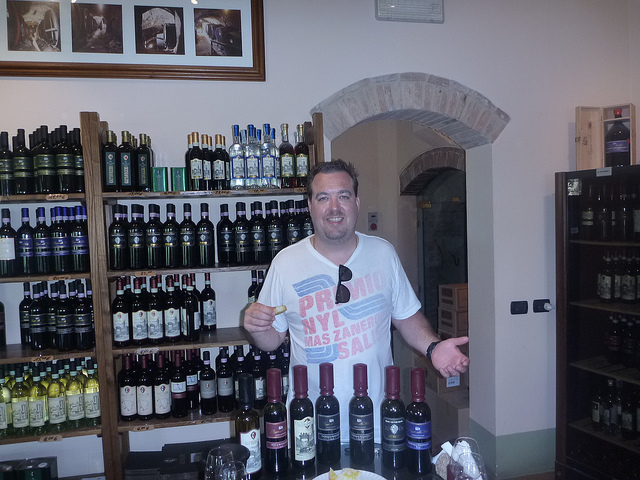What can be inferred about the man's mood or situation? The man has a broad smile and seems to be holding a bottle up as if presenting or offering it. His relaxed posture and joyful expression could indicate he is sharing his passion for the products, perhaps during a tasting event or as a knowledgeable attendant recommending selections to customers. 